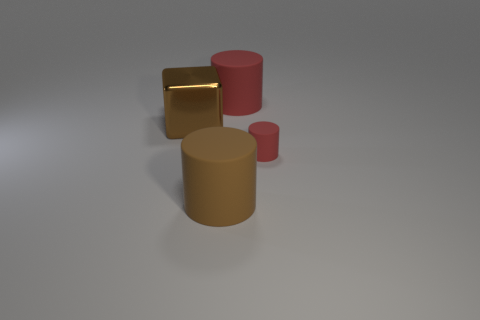Subtract all big red cylinders. How many cylinders are left? 2 Subtract 1 cylinders. How many cylinders are left? 2 Subtract all red cylinders. How many cylinders are left? 1 Add 2 tiny things. How many objects exist? 6 Subtract all cylinders. How many objects are left? 1 Add 4 brown matte things. How many brown matte things are left? 5 Add 3 large rubber objects. How many large rubber objects exist? 5 Subtract 0 purple blocks. How many objects are left? 4 Subtract all cyan cylinders. Subtract all green cubes. How many cylinders are left? 3 Subtract all yellow balls. How many green cylinders are left? 0 